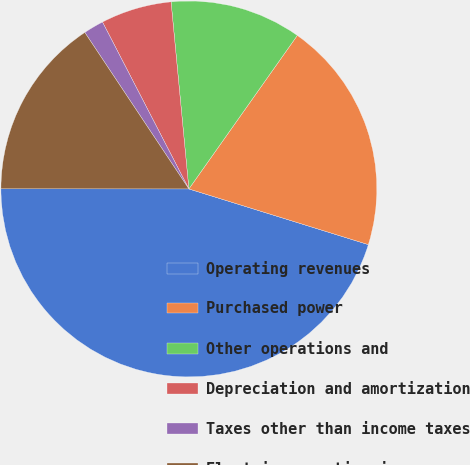Convert chart to OTSL. <chart><loc_0><loc_0><loc_500><loc_500><pie_chart><fcel>Operating revenues<fcel>Purchased power<fcel>Other operations and<fcel>Depreciation and amortization<fcel>Taxes other than income taxes<fcel>Electric operating income<nl><fcel>45.22%<fcel>20.0%<fcel>11.3%<fcel>6.09%<fcel>1.74%<fcel>15.65%<nl></chart> 